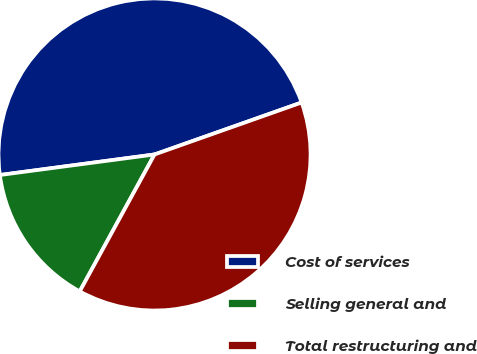<chart> <loc_0><loc_0><loc_500><loc_500><pie_chart><fcel>Cost of services<fcel>Selling general and<fcel>Total restructuring and<nl><fcel>46.69%<fcel>14.94%<fcel>38.36%<nl></chart> 